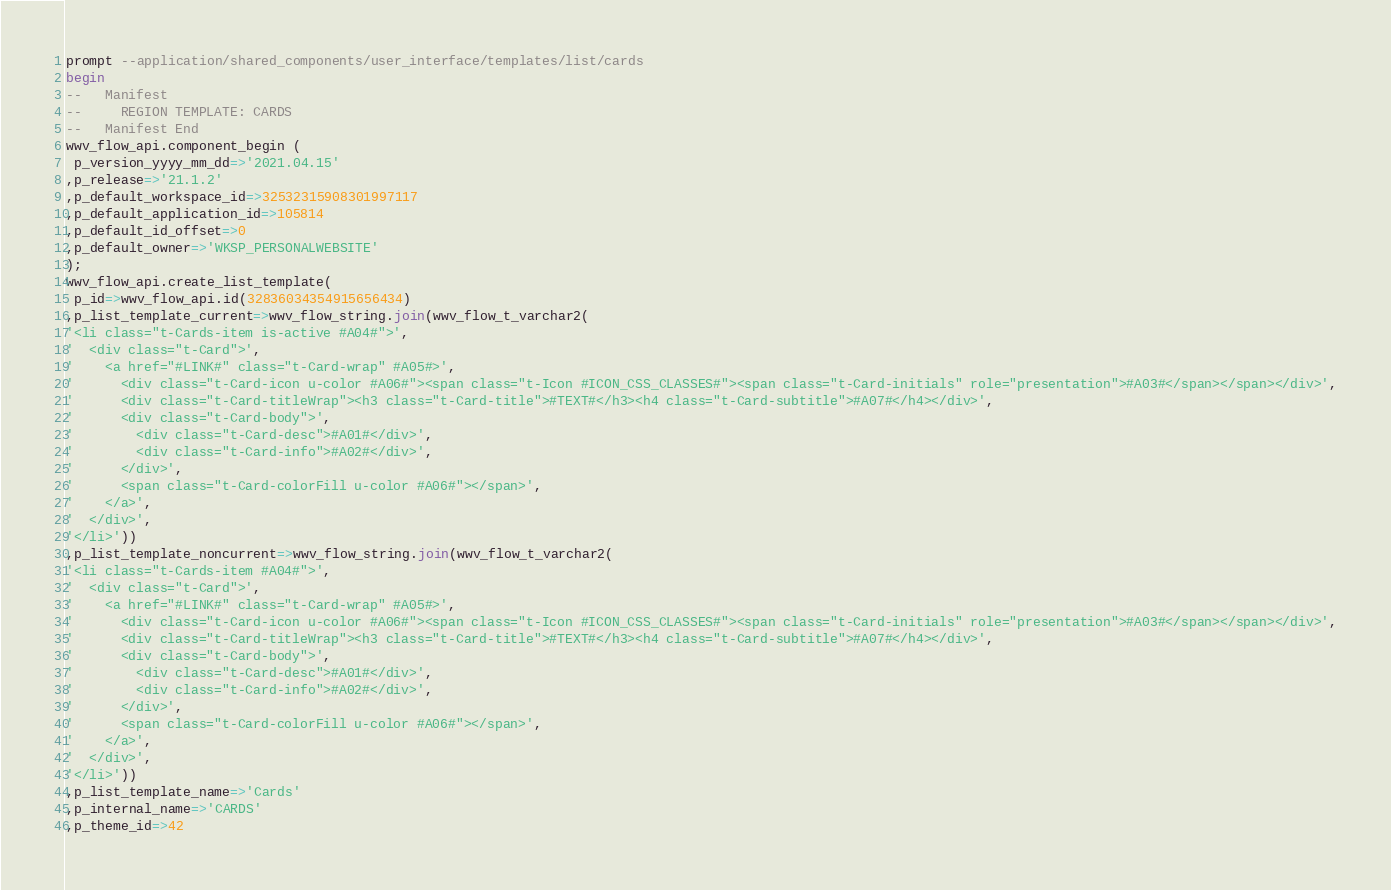<code> <loc_0><loc_0><loc_500><loc_500><_SQL_>prompt --application/shared_components/user_interface/templates/list/cards
begin
--   Manifest
--     REGION TEMPLATE: CARDS
--   Manifest End
wwv_flow_api.component_begin (
 p_version_yyyy_mm_dd=>'2021.04.15'
,p_release=>'21.1.2'
,p_default_workspace_id=>32532315908301997117
,p_default_application_id=>105814
,p_default_id_offset=>0
,p_default_owner=>'WKSP_PERSONALWEBSITE'
);
wwv_flow_api.create_list_template(
 p_id=>wwv_flow_api.id(32836034354915656434)
,p_list_template_current=>wwv_flow_string.join(wwv_flow_t_varchar2(
'<li class="t-Cards-item is-active #A04#">',
'  <div class="t-Card">',
'    <a href="#LINK#" class="t-Card-wrap" #A05#>',
'      <div class="t-Card-icon u-color #A06#"><span class="t-Icon #ICON_CSS_CLASSES#"><span class="t-Card-initials" role="presentation">#A03#</span></span></div>',
'      <div class="t-Card-titleWrap"><h3 class="t-Card-title">#TEXT#</h3><h4 class="t-Card-subtitle">#A07#</h4></div>',
'      <div class="t-Card-body">',
'        <div class="t-Card-desc">#A01#</div>',
'        <div class="t-Card-info">#A02#</div>',
'      </div>',
'      <span class="t-Card-colorFill u-color #A06#"></span>',
'    </a>',
'  </div>',
'</li>'))
,p_list_template_noncurrent=>wwv_flow_string.join(wwv_flow_t_varchar2(
'<li class="t-Cards-item #A04#">',
'  <div class="t-Card">',
'    <a href="#LINK#" class="t-Card-wrap" #A05#>',
'      <div class="t-Card-icon u-color #A06#"><span class="t-Icon #ICON_CSS_CLASSES#"><span class="t-Card-initials" role="presentation">#A03#</span></span></div>',
'      <div class="t-Card-titleWrap"><h3 class="t-Card-title">#TEXT#</h3><h4 class="t-Card-subtitle">#A07#</h4></div>',
'      <div class="t-Card-body">',
'        <div class="t-Card-desc">#A01#</div>',
'        <div class="t-Card-info">#A02#</div>',
'      </div>',
'      <span class="t-Card-colorFill u-color #A06#"></span>',
'    </a>',
'  </div>',
'</li>'))
,p_list_template_name=>'Cards'
,p_internal_name=>'CARDS'
,p_theme_id=>42</code> 